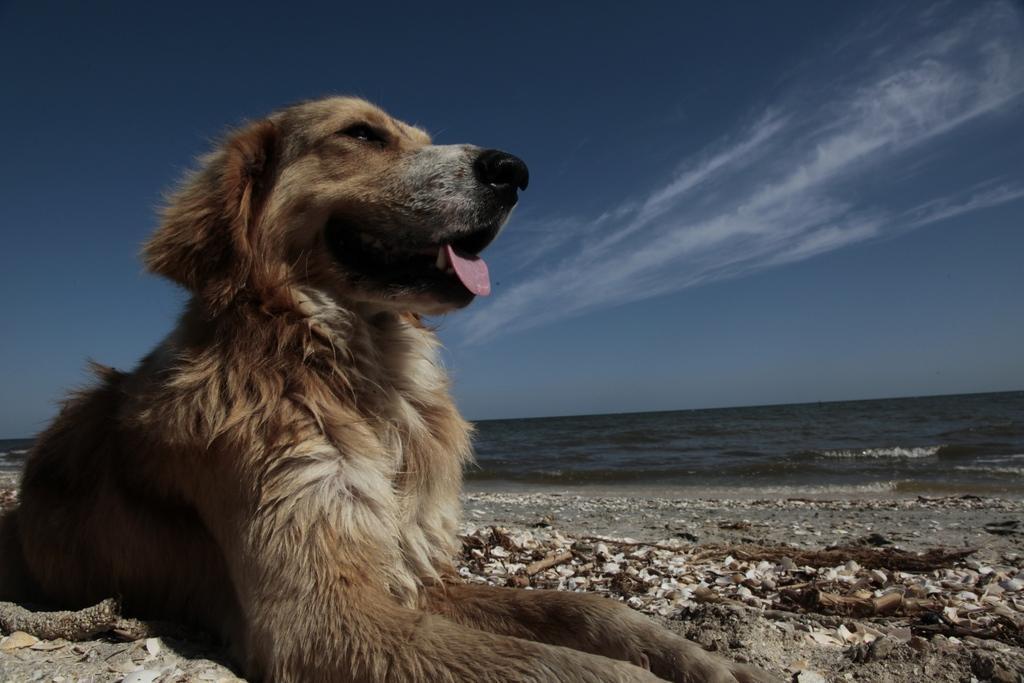In one or two sentences, can you explain what this image depicts? In this image I can see a dog in the foreground in front of the sea, at the top I can see the sky. 